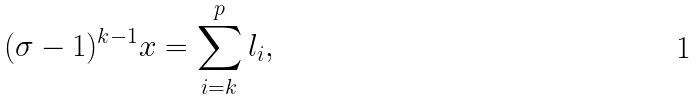Convert formula to latex. <formula><loc_0><loc_0><loc_500><loc_500>( \sigma - 1 ) ^ { k - 1 } x = \sum _ { i = k } ^ { p } l _ { i } ,</formula> 